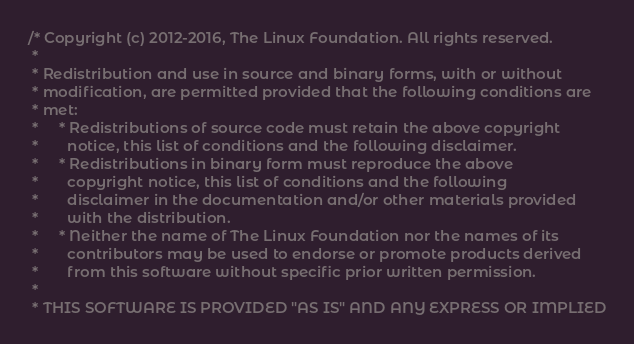Convert code to text. <code><loc_0><loc_0><loc_500><loc_500><_C_>/* Copyright (c) 2012-2016, The Linux Foundation. All rights reserved.
 *
 * Redistribution and use in source and binary forms, with or without
 * modification, are permitted provided that the following conditions are
 * met:
 *     * Redistributions of source code must retain the above copyright
 *       notice, this list of conditions and the following disclaimer.
 *     * Redistributions in binary form must reproduce the above
 *       copyright notice, this list of conditions and the following
 *       disclaimer in the documentation and/or other materials provided
 *       with the distribution.
 *     * Neither the name of The Linux Foundation nor the names of its
 *       contributors may be used to endorse or promote products derived
 *       from this software without specific prior written permission.
 *
 * THIS SOFTWARE IS PROVIDED "AS IS" AND ANY EXPRESS OR IMPLIED</code> 